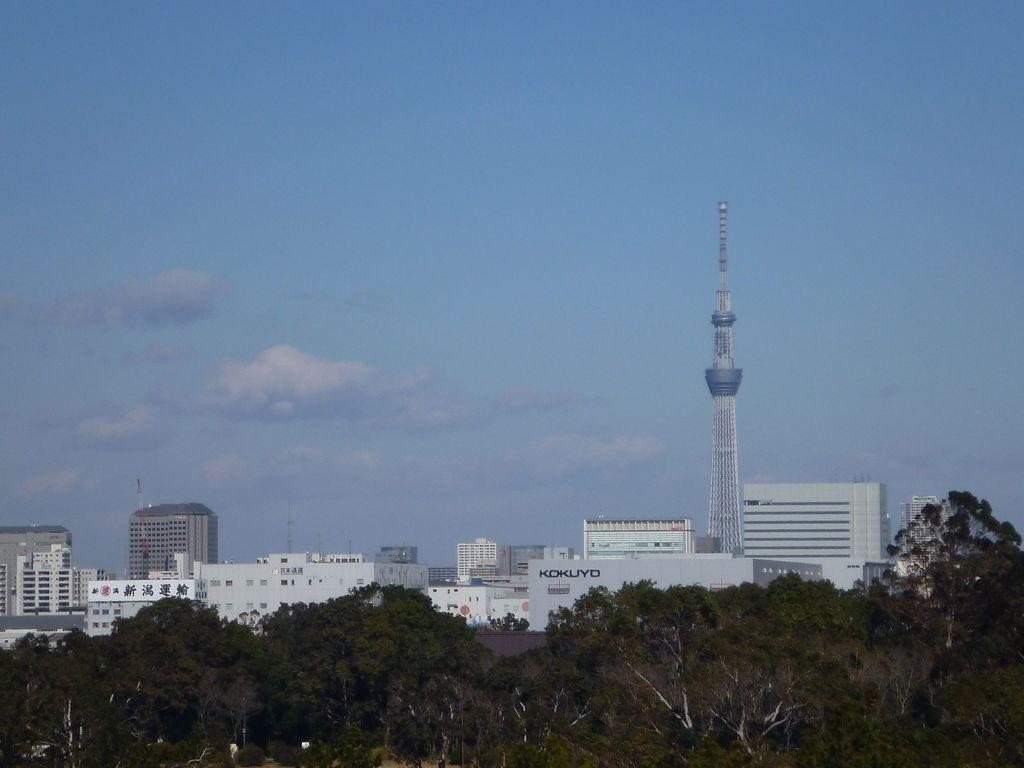What is located in the foreground of the picture? There are trees in the foreground of the picture. What can be seen in the center of the picture? There are buildings in the center of the picture. How would you describe the weather in the image? The sky is sunny, suggesting a clear and bright day. How many horses are grazing in the wilderness in the image? There are no horses or wilderness present in the image; it features trees in the foreground and buildings in the center. 